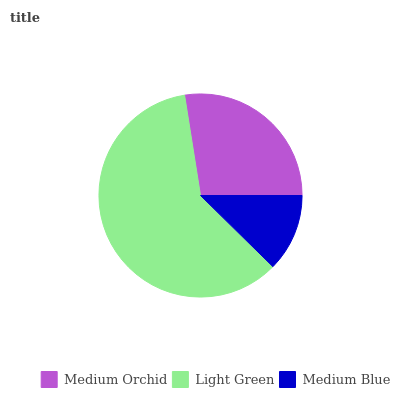Is Medium Blue the minimum?
Answer yes or no. Yes. Is Light Green the maximum?
Answer yes or no. Yes. Is Light Green the minimum?
Answer yes or no. No. Is Medium Blue the maximum?
Answer yes or no. No. Is Light Green greater than Medium Blue?
Answer yes or no. Yes. Is Medium Blue less than Light Green?
Answer yes or no. Yes. Is Medium Blue greater than Light Green?
Answer yes or no. No. Is Light Green less than Medium Blue?
Answer yes or no. No. Is Medium Orchid the high median?
Answer yes or no. Yes. Is Medium Orchid the low median?
Answer yes or no. Yes. Is Medium Blue the high median?
Answer yes or no. No. Is Light Green the low median?
Answer yes or no. No. 